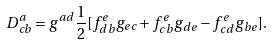<formula> <loc_0><loc_0><loc_500><loc_500>D _ { c b } ^ { a } = g ^ { a d } \frac { 1 } { 2 } [ f _ { d b } ^ { e } g _ { e c } + f _ { c b } ^ { e } g _ { d e } - f _ { c d } ^ { e } g _ { b e } ] .</formula> 